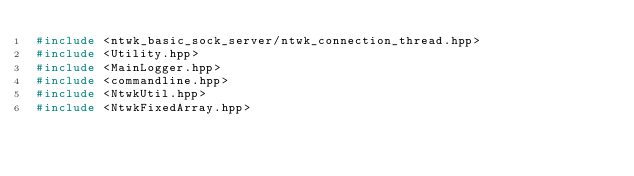<code> <loc_0><loc_0><loc_500><loc_500><_C++_>#include <ntwk_basic_sock_server/ntwk_connection_thread.hpp>
#include <Utility.hpp>
#include <MainLogger.hpp>
#include <commandline.hpp>
#include <NtwkUtil.hpp>
#include <NtwkFixedArray.hpp></code> 